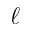<formula> <loc_0><loc_0><loc_500><loc_500>\ell</formula> 